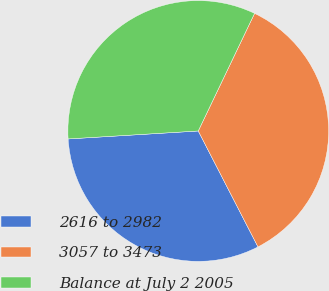<chart> <loc_0><loc_0><loc_500><loc_500><pie_chart><fcel>2616 to 2982<fcel>3057 to 3473<fcel>Balance at July 2 2005<nl><fcel>31.6%<fcel>35.32%<fcel>33.08%<nl></chart> 